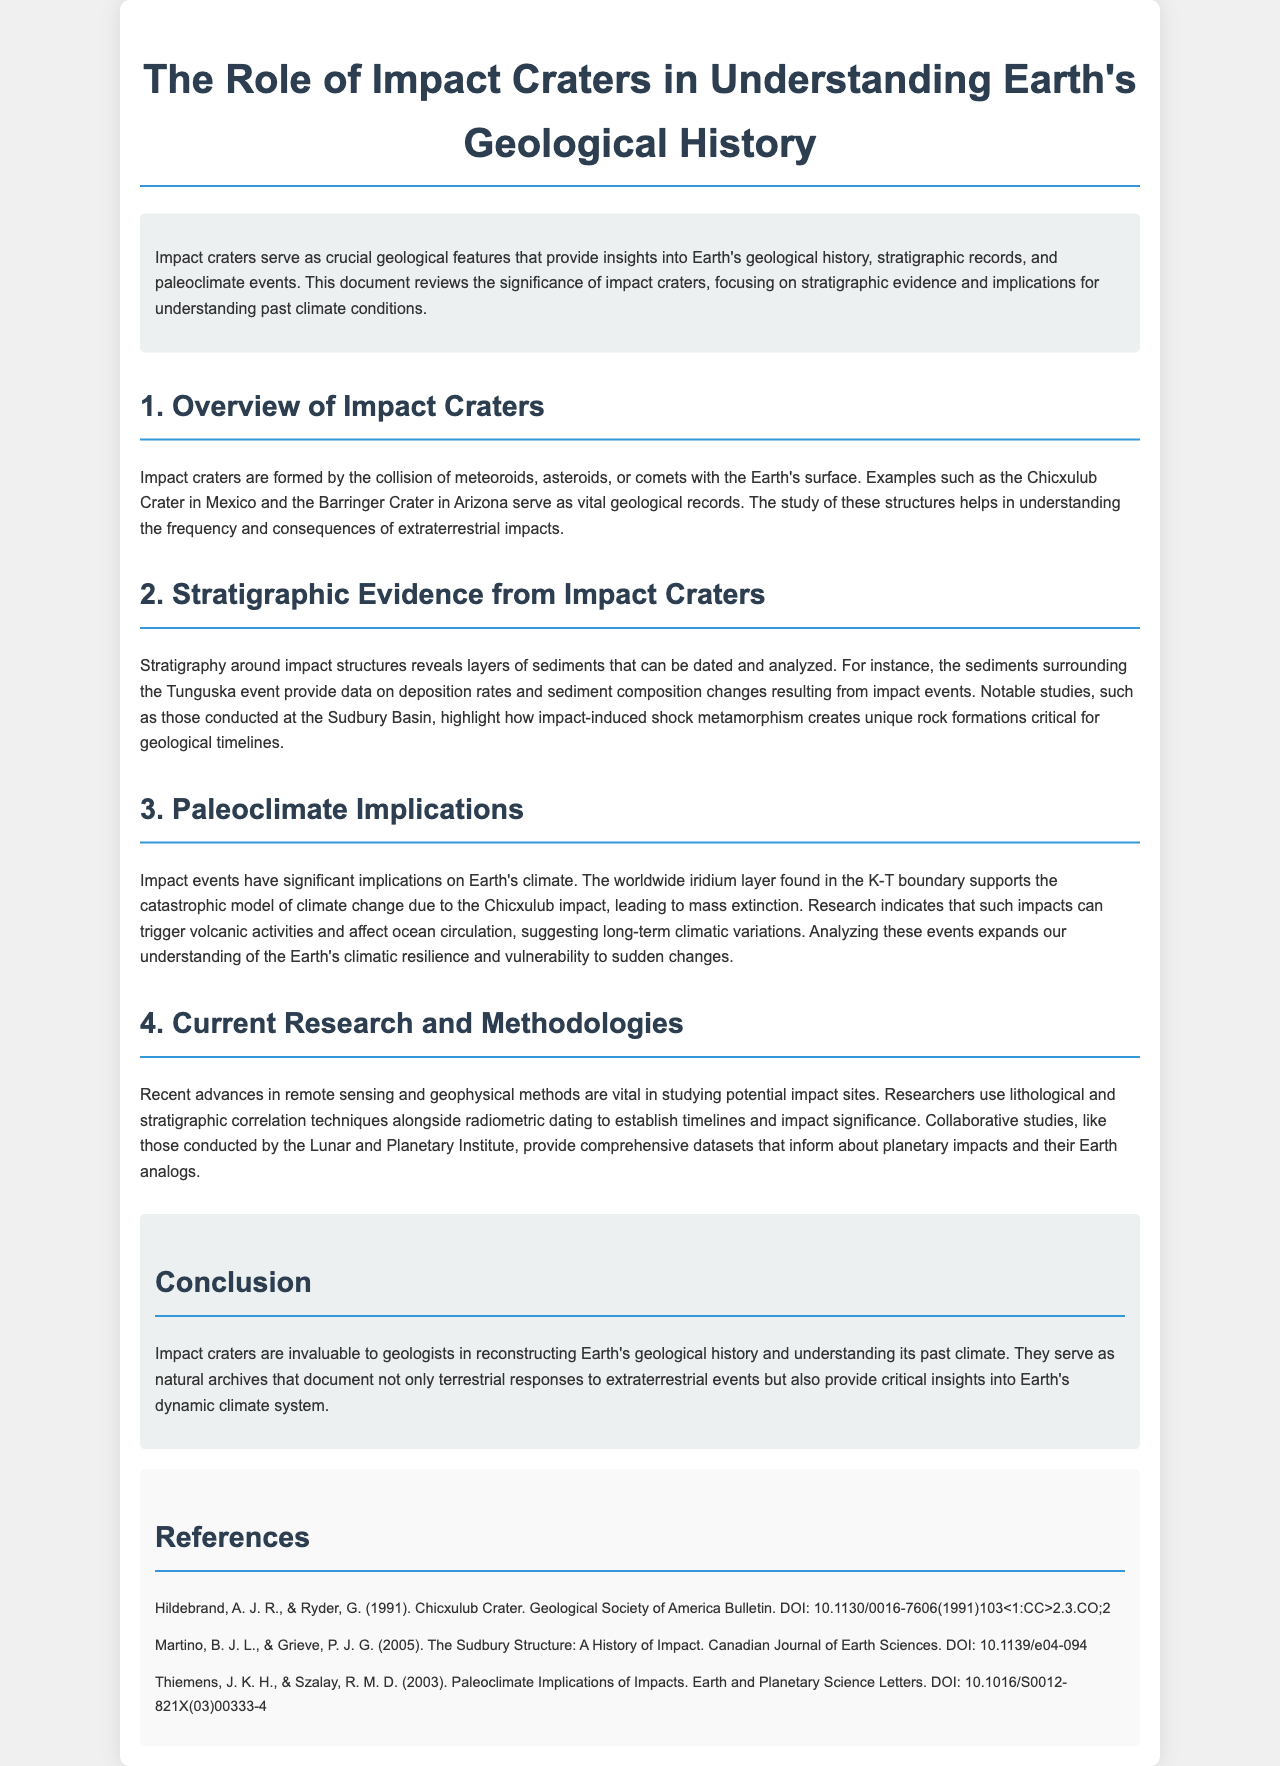What is the main focus of the document? The main focus of the document is on impact craters and their significance in understanding Earth's geological history, stratigraphic records, and paleoclimate events.
Answer: Impact craters Which notable impact crater is mentioned in Mexico? The document mentions the Chicxulub Crater in Mexico as a vital geological record.
Answer: Chicxulub Crater What layer supports the catastrophic model of climate change? The worldwide iridium layer found in the K-T boundary supports the catastrophic model of climate change due to the Chicxulub impact.
Answer: Iridium layer What advances are mentioned in current research methodologies? Recent advances in remote sensing and geophysical methods are vital in studying potential impact sites.
Answer: Remote sensing What is the role of impact craters according to the conclusion? Impact craters serve as natural archives that document terrestrial responses to extraterrestrial events and provide insights into Earth's dynamic climate system.
Answer: Natural archives 